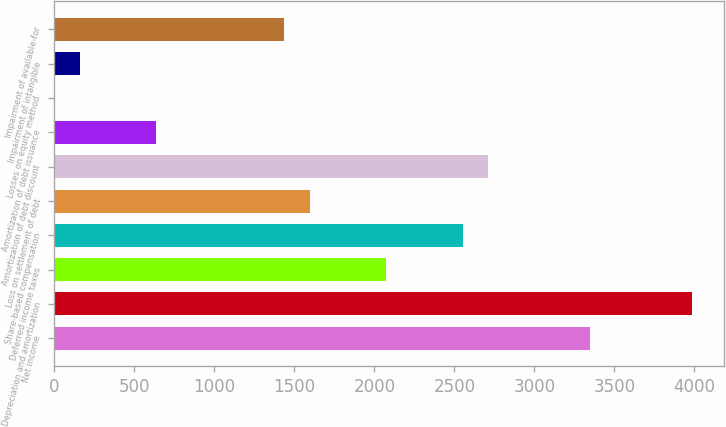Convert chart. <chart><loc_0><loc_0><loc_500><loc_500><bar_chart><fcel>Net income<fcel>Depreciation and amortization<fcel>Deferred income taxes<fcel>Share-based compensation<fcel>Loss on settlement of debt<fcel>Amortization of debt discount<fcel>Amortization of debt issuance<fcel>Losses on equity method<fcel>Impairment of intangible<fcel>Impairment of available-for<nl><fcel>3348.86<fcel>3986.7<fcel>2073.18<fcel>2551.56<fcel>1594.8<fcel>2711.02<fcel>638.04<fcel>0.2<fcel>159.66<fcel>1435.34<nl></chart> 